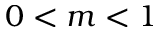Convert formula to latex. <formula><loc_0><loc_0><loc_500><loc_500>0 < m < 1</formula> 